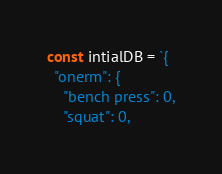<code> <loc_0><loc_0><loc_500><loc_500><_JavaScript_>const intialDB = `{
  "onerm": {
    "bench press": 0,
    "squat": 0,</code> 